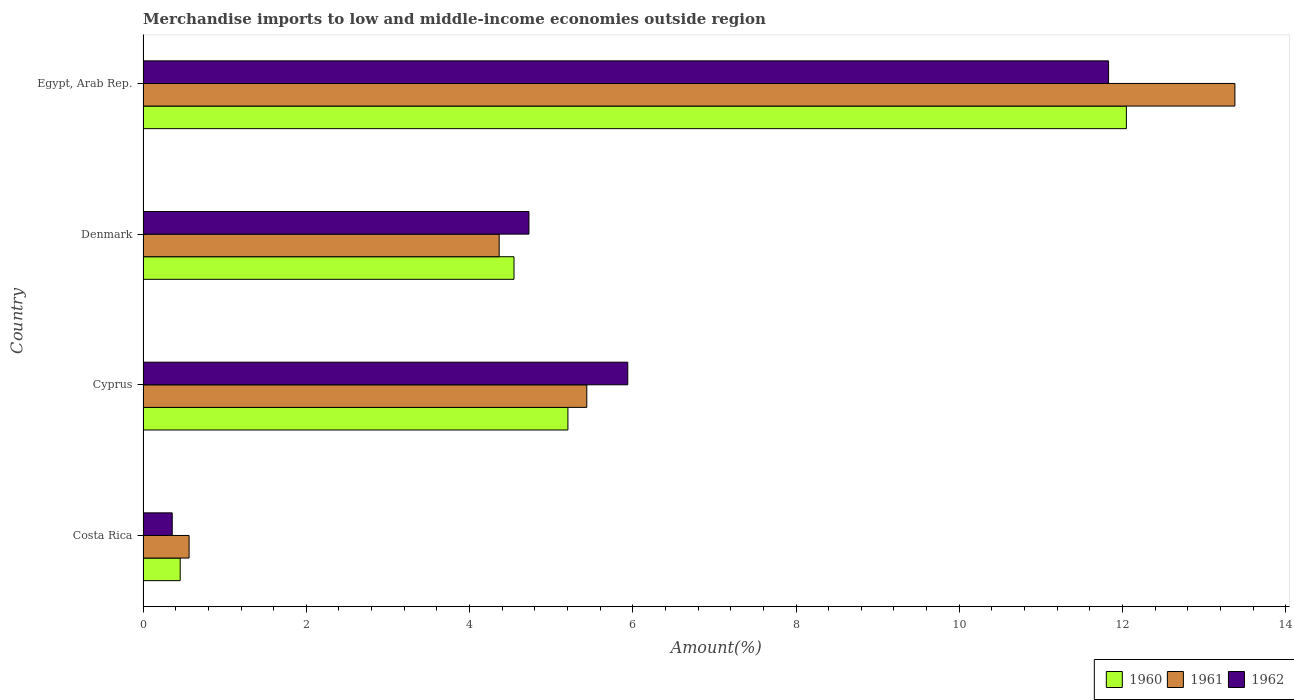How many different coloured bars are there?
Offer a terse response. 3. How many groups of bars are there?
Offer a very short reply. 4. Are the number of bars per tick equal to the number of legend labels?
Offer a very short reply. Yes. Are the number of bars on each tick of the Y-axis equal?
Provide a succinct answer. Yes. What is the label of the 3rd group of bars from the top?
Make the answer very short. Cyprus. In how many cases, is the number of bars for a given country not equal to the number of legend labels?
Your answer should be very brief. 0. What is the percentage of amount earned from merchandise imports in 1960 in Egypt, Arab Rep.?
Ensure brevity in your answer.  12.05. Across all countries, what is the maximum percentage of amount earned from merchandise imports in 1962?
Keep it short and to the point. 11.83. Across all countries, what is the minimum percentage of amount earned from merchandise imports in 1962?
Ensure brevity in your answer.  0.36. In which country was the percentage of amount earned from merchandise imports in 1961 maximum?
Keep it short and to the point. Egypt, Arab Rep. In which country was the percentage of amount earned from merchandise imports in 1960 minimum?
Keep it short and to the point. Costa Rica. What is the total percentage of amount earned from merchandise imports in 1962 in the graph?
Your response must be concise. 22.85. What is the difference between the percentage of amount earned from merchandise imports in 1961 in Costa Rica and that in Cyprus?
Provide a short and direct response. -4.87. What is the difference between the percentage of amount earned from merchandise imports in 1960 in Denmark and the percentage of amount earned from merchandise imports in 1962 in Costa Rica?
Keep it short and to the point. 4.19. What is the average percentage of amount earned from merchandise imports in 1961 per country?
Your answer should be very brief. 5.94. What is the difference between the percentage of amount earned from merchandise imports in 1961 and percentage of amount earned from merchandise imports in 1962 in Denmark?
Provide a short and direct response. -0.36. In how many countries, is the percentage of amount earned from merchandise imports in 1962 greater than 2.4 %?
Offer a very short reply. 3. What is the ratio of the percentage of amount earned from merchandise imports in 1961 in Denmark to that in Egypt, Arab Rep.?
Offer a very short reply. 0.33. Is the percentage of amount earned from merchandise imports in 1960 in Costa Rica less than that in Denmark?
Ensure brevity in your answer.  Yes. Is the difference between the percentage of amount earned from merchandise imports in 1961 in Costa Rica and Denmark greater than the difference between the percentage of amount earned from merchandise imports in 1962 in Costa Rica and Denmark?
Keep it short and to the point. Yes. What is the difference between the highest and the second highest percentage of amount earned from merchandise imports in 1962?
Keep it short and to the point. 5.89. What is the difference between the highest and the lowest percentage of amount earned from merchandise imports in 1960?
Provide a short and direct response. 11.59. What does the 1st bar from the top in Denmark represents?
Your response must be concise. 1962. What does the 2nd bar from the bottom in Costa Rica represents?
Provide a succinct answer. 1961. How many bars are there?
Provide a succinct answer. 12. How many countries are there in the graph?
Provide a succinct answer. 4. Are the values on the major ticks of X-axis written in scientific E-notation?
Ensure brevity in your answer.  No. Does the graph contain any zero values?
Your answer should be very brief. No. Does the graph contain grids?
Your answer should be very brief. No. How are the legend labels stacked?
Offer a terse response. Horizontal. What is the title of the graph?
Ensure brevity in your answer.  Merchandise imports to low and middle-income economies outside region. Does "2015" appear as one of the legend labels in the graph?
Provide a short and direct response. No. What is the label or title of the X-axis?
Give a very brief answer. Amount(%). What is the Amount(%) of 1960 in Costa Rica?
Your response must be concise. 0.45. What is the Amount(%) of 1961 in Costa Rica?
Your answer should be very brief. 0.56. What is the Amount(%) of 1962 in Costa Rica?
Give a very brief answer. 0.36. What is the Amount(%) of 1960 in Cyprus?
Offer a very short reply. 5.21. What is the Amount(%) of 1961 in Cyprus?
Your response must be concise. 5.44. What is the Amount(%) in 1962 in Cyprus?
Provide a short and direct response. 5.94. What is the Amount(%) of 1960 in Denmark?
Offer a very short reply. 4.54. What is the Amount(%) of 1961 in Denmark?
Your answer should be very brief. 4.36. What is the Amount(%) in 1962 in Denmark?
Keep it short and to the point. 4.73. What is the Amount(%) of 1960 in Egypt, Arab Rep.?
Give a very brief answer. 12.05. What is the Amount(%) of 1961 in Egypt, Arab Rep.?
Provide a succinct answer. 13.38. What is the Amount(%) in 1962 in Egypt, Arab Rep.?
Offer a terse response. 11.83. Across all countries, what is the maximum Amount(%) of 1960?
Your answer should be compact. 12.05. Across all countries, what is the maximum Amount(%) in 1961?
Offer a very short reply. 13.38. Across all countries, what is the maximum Amount(%) in 1962?
Give a very brief answer. 11.83. Across all countries, what is the minimum Amount(%) of 1960?
Offer a very short reply. 0.45. Across all countries, what is the minimum Amount(%) of 1961?
Your answer should be very brief. 0.56. Across all countries, what is the minimum Amount(%) in 1962?
Make the answer very short. 0.36. What is the total Amount(%) in 1960 in the graph?
Your answer should be very brief. 22.25. What is the total Amount(%) in 1961 in the graph?
Give a very brief answer. 23.74. What is the total Amount(%) of 1962 in the graph?
Provide a succinct answer. 22.85. What is the difference between the Amount(%) of 1960 in Costa Rica and that in Cyprus?
Offer a terse response. -4.75. What is the difference between the Amount(%) in 1961 in Costa Rica and that in Cyprus?
Your answer should be very brief. -4.87. What is the difference between the Amount(%) in 1962 in Costa Rica and that in Cyprus?
Make the answer very short. -5.58. What is the difference between the Amount(%) in 1960 in Costa Rica and that in Denmark?
Your answer should be very brief. -4.09. What is the difference between the Amount(%) of 1961 in Costa Rica and that in Denmark?
Make the answer very short. -3.8. What is the difference between the Amount(%) in 1962 in Costa Rica and that in Denmark?
Make the answer very short. -4.37. What is the difference between the Amount(%) of 1960 in Costa Rica and that in Egypt, Arab Rep.?
Your response must be concise. -11.59. What is the difference between the Amount(%) in 1961 in Costa Rica and that in Egypt, Arab Rep.?
Give a very brief answer. -12.81. What is the difference between the Amount(%) in 1962 in Costa Rica and that in Egypt, Arab Rep.?
Offer a terse response. -11.47. What is the difference between the Amount(%) of 1960 in Cyprus and that in Denmark?
Make the answer very short. 0.66. What is the difference between the Amount(%) of 1961 in Cyprus and that in Denmark?
Offer a terse response. 1.07. What is the difference between the Amount(%) in 1962 in Cyprus and that in Denmark?
Provide a succinct answer. 1.21. What is the difference between the Amount(%) of 1960 in Cyprus and that in Egypt, Arab Rep.?
Offer a terse response. -6.84. What is the difference between the Amount(%) of 1961 in Cyprus and that in Egypt, Arab Rep.?
Provide a short and direct response. -7.94. What is the difference between the Amount(%) of 1962 in Cyprus and that in Egypt, Arab Rep.?
Offer a terse response. -5.89. What is the difference between the Amount(%) in 1960 in Denmark and that in Egypt, Arab Rep.?
Your answer should be compact. -7.5. What is the difference between the Amount(%) in 1961 in Denmark and that in Egypt, Arab Rep.?
Keep it short and to the point. -9.01. What is the difference between the Amount(%) of 1962 in Denmark and that in Egypt, Arab Rep.?
Ensure brevity in your answer.  -7.1. What is the difference between the Amount(%) in 1960 in Costa Rica and the Amount(%) in 1961 in Cyprus?
Give a very brief answer. -4.98. What is the difference between the Amount(%) of 1960 in Costa Rica and the Amount(%) of 1962 in Cyprus?
Offer a very short reply. -5.48. What is the difference between the Amount(%) of 1961 in Costa Rica and the Amount(%) of 1962 in Cyprus?
Provide a short and direct response. -5.38. What is the difference between the Amount(%) of 1960 in Costa Rica and the Amount(%) of 1961 in Denmark?
Your answer should be compact. -3.91. What is the difference between the Amount(%) of 1960 in Costa Rica and the Amount(%) of 1962 in Denmark?
Offer a terse response. -4.27. What is the difference between the Amount(%) in 1961 in Costa Rica and the Amount(%) in 1962 in Denmark?
Provide a succinct answer. -4.16. What is the difference between the Amount(%) of 1960 in Costa Rica and the Amount(%) of 1961 in Egypt, Arab Rep.?
Keep it short and to the point. -12.92. What is the difference between the Amount(%) in 1960 in Costa Rica and the Amount(%) in 1962 in Egypt, Arab Rep.?
Offer a very short reply. -11.37. What is the difference between the Amount(%) of 1961 in Costa Rica and the Amount(%) of 1962 in Egypt, Arab Rep.?
Provide a short and direct response. -11.27. What is the difference between the Amount(%) of 1960 in Cyprus and the Amount(%) of 1961 in Denmark?
Make the answer very short. 0.84. What is the difference between the Amount(%) of 1960 in Cyprus and the Amount(%) of 1962 in Denmark?
Your answer should be very brief. 0.48. What is the difference between the Amount(%) of 1961 in Cyprus and the Amount(%) of 1962 in Denmark?
Ensure brevity in your answer.  0.71. What is the difference between the Amount(%) in 1960 in Cyprus and the Amount(%) in 1961 in Egypt, Arab Rep.?
Your answer should be compact. -8.17. What is the difference between the Amount(%) of 1960 in Cyprus and the Amount(%) of 1962 in Egypt, Arab Rep.?
Ensure brevity in your answer.  -6.62. What is the difference between the Amount(%) of 1961 in Cyprus and the Amount(%) of 1962 in Egypt, Arab Rep.?
Your response must be concise. -6.39. What is the difference between the Amount(%) of 1960 in Denmark and the Amount(%) of 1961 in Egypt, Arab Rep.?
Provide a succinct answer. -8.83. What is the difference between the Amount(%) of 1960 in Denmark and the Amount(%) of 1962 in Egypt, Arab Rep.?
Ensure brevity in your answer.  -7.28. What is the difference between the Amount(%) in 1961 in Denmark and the Amount(%) in 1962 in Egypt, Arab Rep.?
Provide a short and direct response. -7.47. What is the average Amount(%) of 1960 per country?
Make the answer very short. 5.56. What is the average Amount(%) in 1961 per country?
Ensure brevity in your answer.  5.94. What is the average Amount(%) of 1962 per country?
Ensure brevity in your answer.  5.71. What is the difference between the Amount(%) in 1960 and Amount(%) in 1961 in Costa Rica?
Make the answer very short. -0.11. What is the difference between the Amount(%) in 1960 and Amount(%) in 1962 in Costa Rica?
Make the answer very short. 0.1. What is the difference between the Amount(%) in 1961 and Amount(%) in 1962 in Costa Rica?
Your response must be concise. 0.21. What is the difference between the Amount(%) of 1960 and Amount(%) of 1961 in Cyprus?
Provide a short and direct response. -0.23. What is the difference between the Amount(%) of 1960 and Amount(%) of 1962 in Cyprus?
Offer a terse response. -0.73. What is the difference between the Amount(%) of 1961 and Amount(%) of 1962 in Cyprus?
Keep it short and to the point. -0.5. What is the difference between the Amount(%) of 1960 and Amount(%) of 1961 in Denmark?
Keep it short and to the point. 0.18. What is the difference between the Amount(%) of 1960 and Amount(%) of 1962 in Denmark?
Provide a short and direct response. -0.18. What is the difference between the Amount(%) in 1961 and Amount(%) in 1962 in Denmark?
Offer a very short reply. -0.36. What is the difference between the Amount(%) of 1960 and Amount(%) of 1961 in Egypt, Arab Rep.?
Give a very brief answer. -1.33. What is the difference between the Amount(%) in 1960 and Amount(%) in 1962 in Egypt, Arab Rep.?
Give a very brief answer. 0.22. What is the difference between the Amount(%) of 1961 and Amount(%) of 1962 in Egypt, Arab Rep.?
Make the answer very short. 1.55. What is the ratio of the Amount(%) in 1960 in Costa Rica to that in Cyprus?
Ensure brevity in your answer.  0.09. What is the ratio of the Amount(%) in 1961 in Costa Rica to that in Cyprus?
Provide a short and direct response. 0.1. What is the ratio of the Amount(%) of 1962 in Costa Rica to that in Cyprus?
Give a very brief answer. 0.06. What is the ratio of the Amount(%) in 1960 in Costa Rica to that in Denmark?
Offer a terse response. 0.1. What is the ratio of the Amount(%) in 1961 in Costa Rica to that in Denmark?
Your response must be concise. 0.13. What is the ratio of the Amount(%) of 1962 in Costa Rica to that in Denmark?
Your answer should be compact. 0.08. What is the ratio of the Amount(%) in 1960 in Costa Rica to that in Egypt, Arab Rep.?
Your answer should be very brief. 0.04. What is the ratio of the Amount(%) of 1961 in Costa Rica to that in Egypt, Arab Rep.?
Make the answer very short. 0.04. What is the ratio of the Amount(%) of 1962 in Costa Rica to that in Egypt, Arab Rep.?
Your response must be concise. 0.03. What is the ratio of the Amount(%) in 1960 in Cyprus to that in Denmark?
Offer a terse response. 1.15. What is the ratio of the Amount(%) of 1961 in Cyprus to that in Denmark?
Offer a very short reply. 1.25. What is the ratio of the Amount(%) of 1962 in Cyprus to that in Denmark?
Offer a terse response. 1.26. What is the ratio of the Amount(%) of 1960 in Cyprus to that in Egypt, Arab Rep.?
Your answer should be compact. 0.43. What is the ratio of the Amount(%) in 1961 in Cyprus to that in Egypt, Arab Rep.?
Provide a short and direct response. 0.41. What is the ratio of the Amount(%) in 1962 in Cyprus to that in Egypt, Arab Rep.?
Keep it short and to the point. 0.5. What is the ratio of the Amount(%) of 1960 in Denmark to that in Egypt, Arab Rep.?
Provide a succinct answer. 0.38. What is the ratio of the Amount(%) in 1961 in Denmark to that in Egypt, Arab Rep.?
Your answer should be compact. 0.33. What is the ratio of the Amount(%) in 1962 in Denmark to that in Egypt, Arab Rep.?
Your response must be concise. 0.4. What is the difference between the highest and the second highest Amount(%) of 1960?
Offer a very short reply. 6.84. What is the difference between the highest and the second highest Amount(%) of 1961?
Offer a very short reply. 7.94. What is the difference between the highest and the second highest Amount(%) of 1962?
Offer a very short reply. 5.89. What is the difference between the highest and the lowest Amount(%) of 1960?
Ensure brevity in your answer.  11.59. What is the difference between the highest and the lowest Amount(%) of 1961?
Offer a very short reply. 12.81. What is the difference between the highest and the lowest Amount(%) of 1962?
Give a very brief answer. 11.47. 